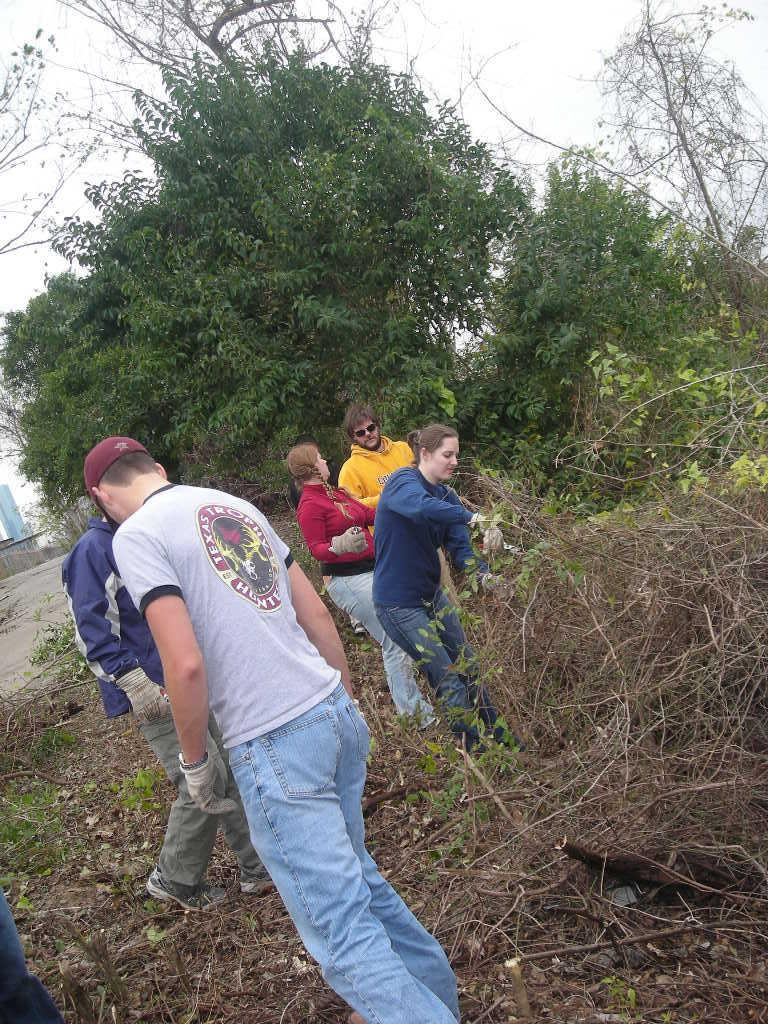Who or what can be seen in the image? There are people in the image. What is located on the right side of the image? There is a pile of twigs on the right side of the image. What can be seen in the background of the image? There are trees and the sky visible in the background of the image. What type of corn can be seen growing on the stage in the image? There is no stage or corn present in the image. 